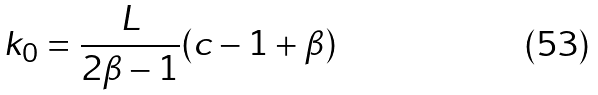Convert formula to latex. <formula><loc_0><loc_0><loc_500><loc_500>k _ { 0 } = \frac { L } { 2 \beta - 1 } ( c - 1 + \beta )</formula> 